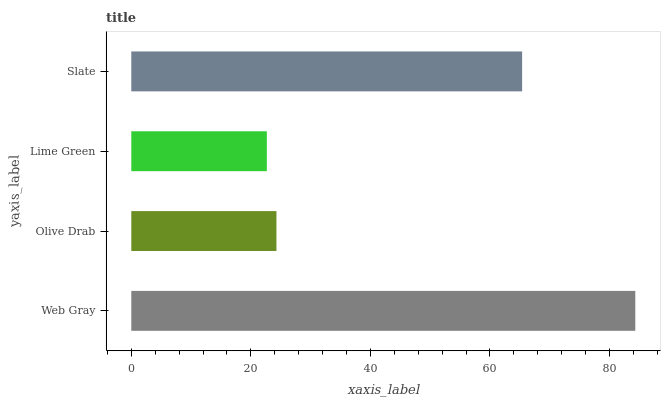Is Lime Green the minimum?
Answer yes or no. Yes. Is Web Gray the maximum?
Answer yes or no. Yes. Is Olive Drab the minimum?
Answer yes or no. No. Is Olive Drab the maximum?
Answer yes or no. No. Is Web Gray greater than Olive Drab?
Answer yes or no. Yes. Is Olive Drab less than Web Gray?
Answer yes or no. Yes. Is Olive Drab greater than Web Gray?
Answer yes or no. No. Is Web Gray less than Olive Drab?
Answer yes or no. No. Is Slate the high median?
Answer yes or no. Yes. Is Olive Drab the low median?
Answer yes or no. Yes. Is Web Gray the high median?
Answer yes or no. No. Is Web Gray the low median?
Answer yes or no. No. 